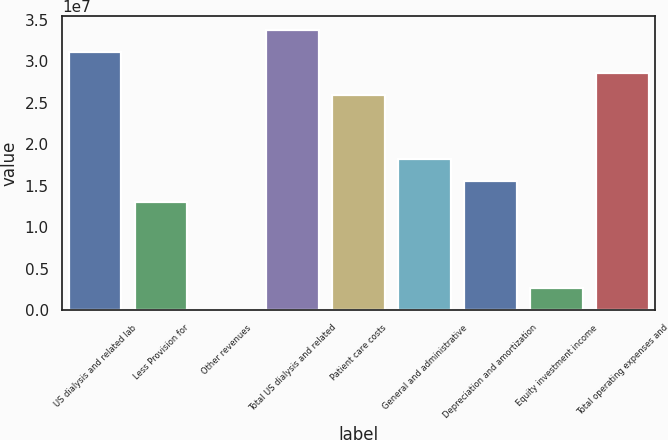Convert chart. <chart><loc_0><loc_0><loc_500><loc_500><bar_chart><fcel>US dialysis and related lab<fcel>Less Provision for<fcel>Other revenues<fcel>Total US dialysis and related<fcel>Patient care costs<fcel>General and administrative<fcel>Depreciation and amortization<fcel>Equity investment income<fcel>Total operating expenses and<nl><fcel>3.11841e+07<fcel>1.29934e+07<fcel>14<fcel>3.37827e+07<fcel>2.59867e+07<fcel>1.81907e+07<fcel>1.5592e+07<fcel>2.59868e+06<fcel>2.85854e+07<nl></chart> 